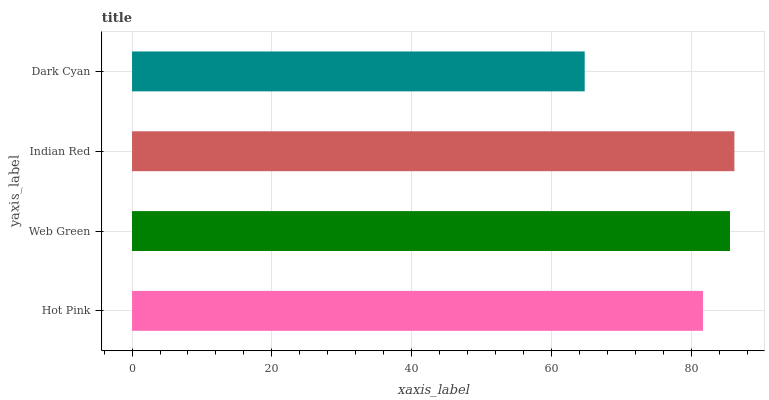Is Dark Cyan the minimum?
Answer yes or no. Yes. Is Indian Red the maximum?
Answer yes or no. Yes. Is Web Green the minimum?
Answer yes or no. No. Is Web Green the maximum?
Answer yes or no. No. Is Web Green greater than Hot Pink?
Answer yes or no. Yes. Is Hot Pink less than Web Green?
Answer yes or no. Yes. Is Hot Pink greater than Web Green?
Answer yes or no. No. Is Web Green less than Hot Pink?
Answer yes or no. No. Is Web Green the high median?
Answer yes or no. Yes. Is Hot Pink the low median?
Answer yes or no. Yes. Is Dark Cyan the high median?
Answer yes or no. No. Is Indian Red the low median?
Answer yes or no. No. 